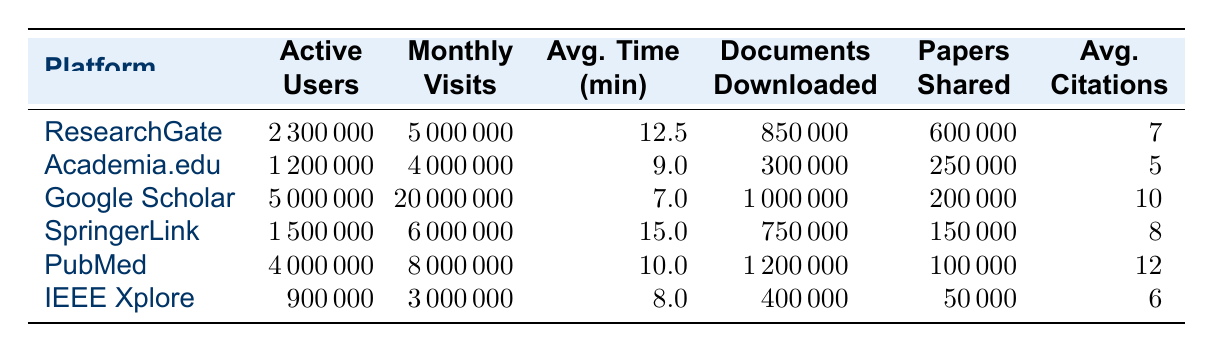What is the number of active users on Google Scholar? The table shows that Google Scholar has 5,000,000 active users listed under the "Active Users" column.
Answer: 5,000,000 Which platform has the highest average time spent per session? By comparing the "Avg. Time (min)" column, ResearchGate has the highest value at 12.5 minutes.
Answer: ResearchGate How many documents were downloaded from PubMed? The table indicates that PubMed has 1,200,000 documents downloaded.
Answer: 1,200,000 What is the total number of active users across all platforms listed? To find this, sum the number of active users: 2,300,000 + 1,200,000 + 5,000,000 + 1,500,000 + 4,000,000 + 900,000 = 15,900,000.
Answer: 15,900,000 Does Academia.edu have more monthly visits than IEEE Xplore? Comparing the "Monthly Visits" column, Academia.edu has 4,000,000 visits while IEEE Xplore has 3,000,000 visits, so yes, Academia.edu has more visits.
Answer: Yes What is the average number of documents downloaded per active user for SpringerLink? The number of documents downloaded is 750,000, and the number of active users is 1,500,000. To find the average per user, divide 750,000 by 1,500,000, which equals 0.5 documents per user.
Answer: 0.5 Which platform, on average, has the most citations per paper? By looking at the "Avg. Citations" column, PubMed shows the highest average at 12 citations per paper.
Answer: PubMed What is the difference in monthly visits between Google Scholar and ResearchGate? Google Scholar has 20,000,000 monthly visits and ResearchGate has 5,000,000. The difference is 20,000,000 - 5,000,000 = 15,000,000.
Answer: 15,000,000 What percentage of the total documents downloaded came from Google Scholar? Total documents downloaded is 850,000 + 300,000 + 1,000,000 + 750,000 + 1,200,000 + 400,000 = 4,600,000. Google Scholar's downloads are 1,000,000. The percentage is (1,000,000 / 4,600,000) * 100 ≈ 21.74%.
Answer: 21.74% Is the average time spent per session greater than 10 minutes for all platforms? Checking the "Avg. Time (min)" column, ResearchGate (12.5), SpringerLink (15.0), and PubMed (10.0) exceed 10 minutes, while Academia.edu (9.0) and IEEE Xplore (8.0) do not. Thus, not all platforms have more than 10 minutes.
Answer: No If you combine the number of papers shared by ResearchGate and SpringerLink, how many papers would that be? ResearchGate shares 600,000 papers while SpringerLink shares 150,000. Summing these gives 600,000 + 150,000 = 750,000 papers shared.
Answer: 750,000 